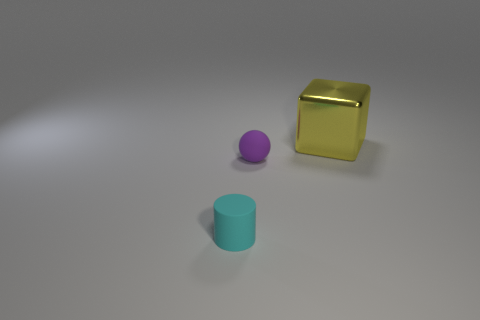Add 1 big balls. How many objects exist? 4 Add 2 small metallic cylinders. How many small metallic cylinders exist? 2 Subtract 0 blue cubes. How many objects are left? 3 Subtract all cylinders. How many objects are left? 2 Subtract all gray cylinders. Subtract all blue balls. How many cylinders are left? 1 Subtract all red balls. How many purple cubes are left? 0 Subtract all yellow metallic cubes. Subtract all tiny yellow blocks. How many objects are left? 2 Add 1 metal objects. How many metal objects are left? 2 